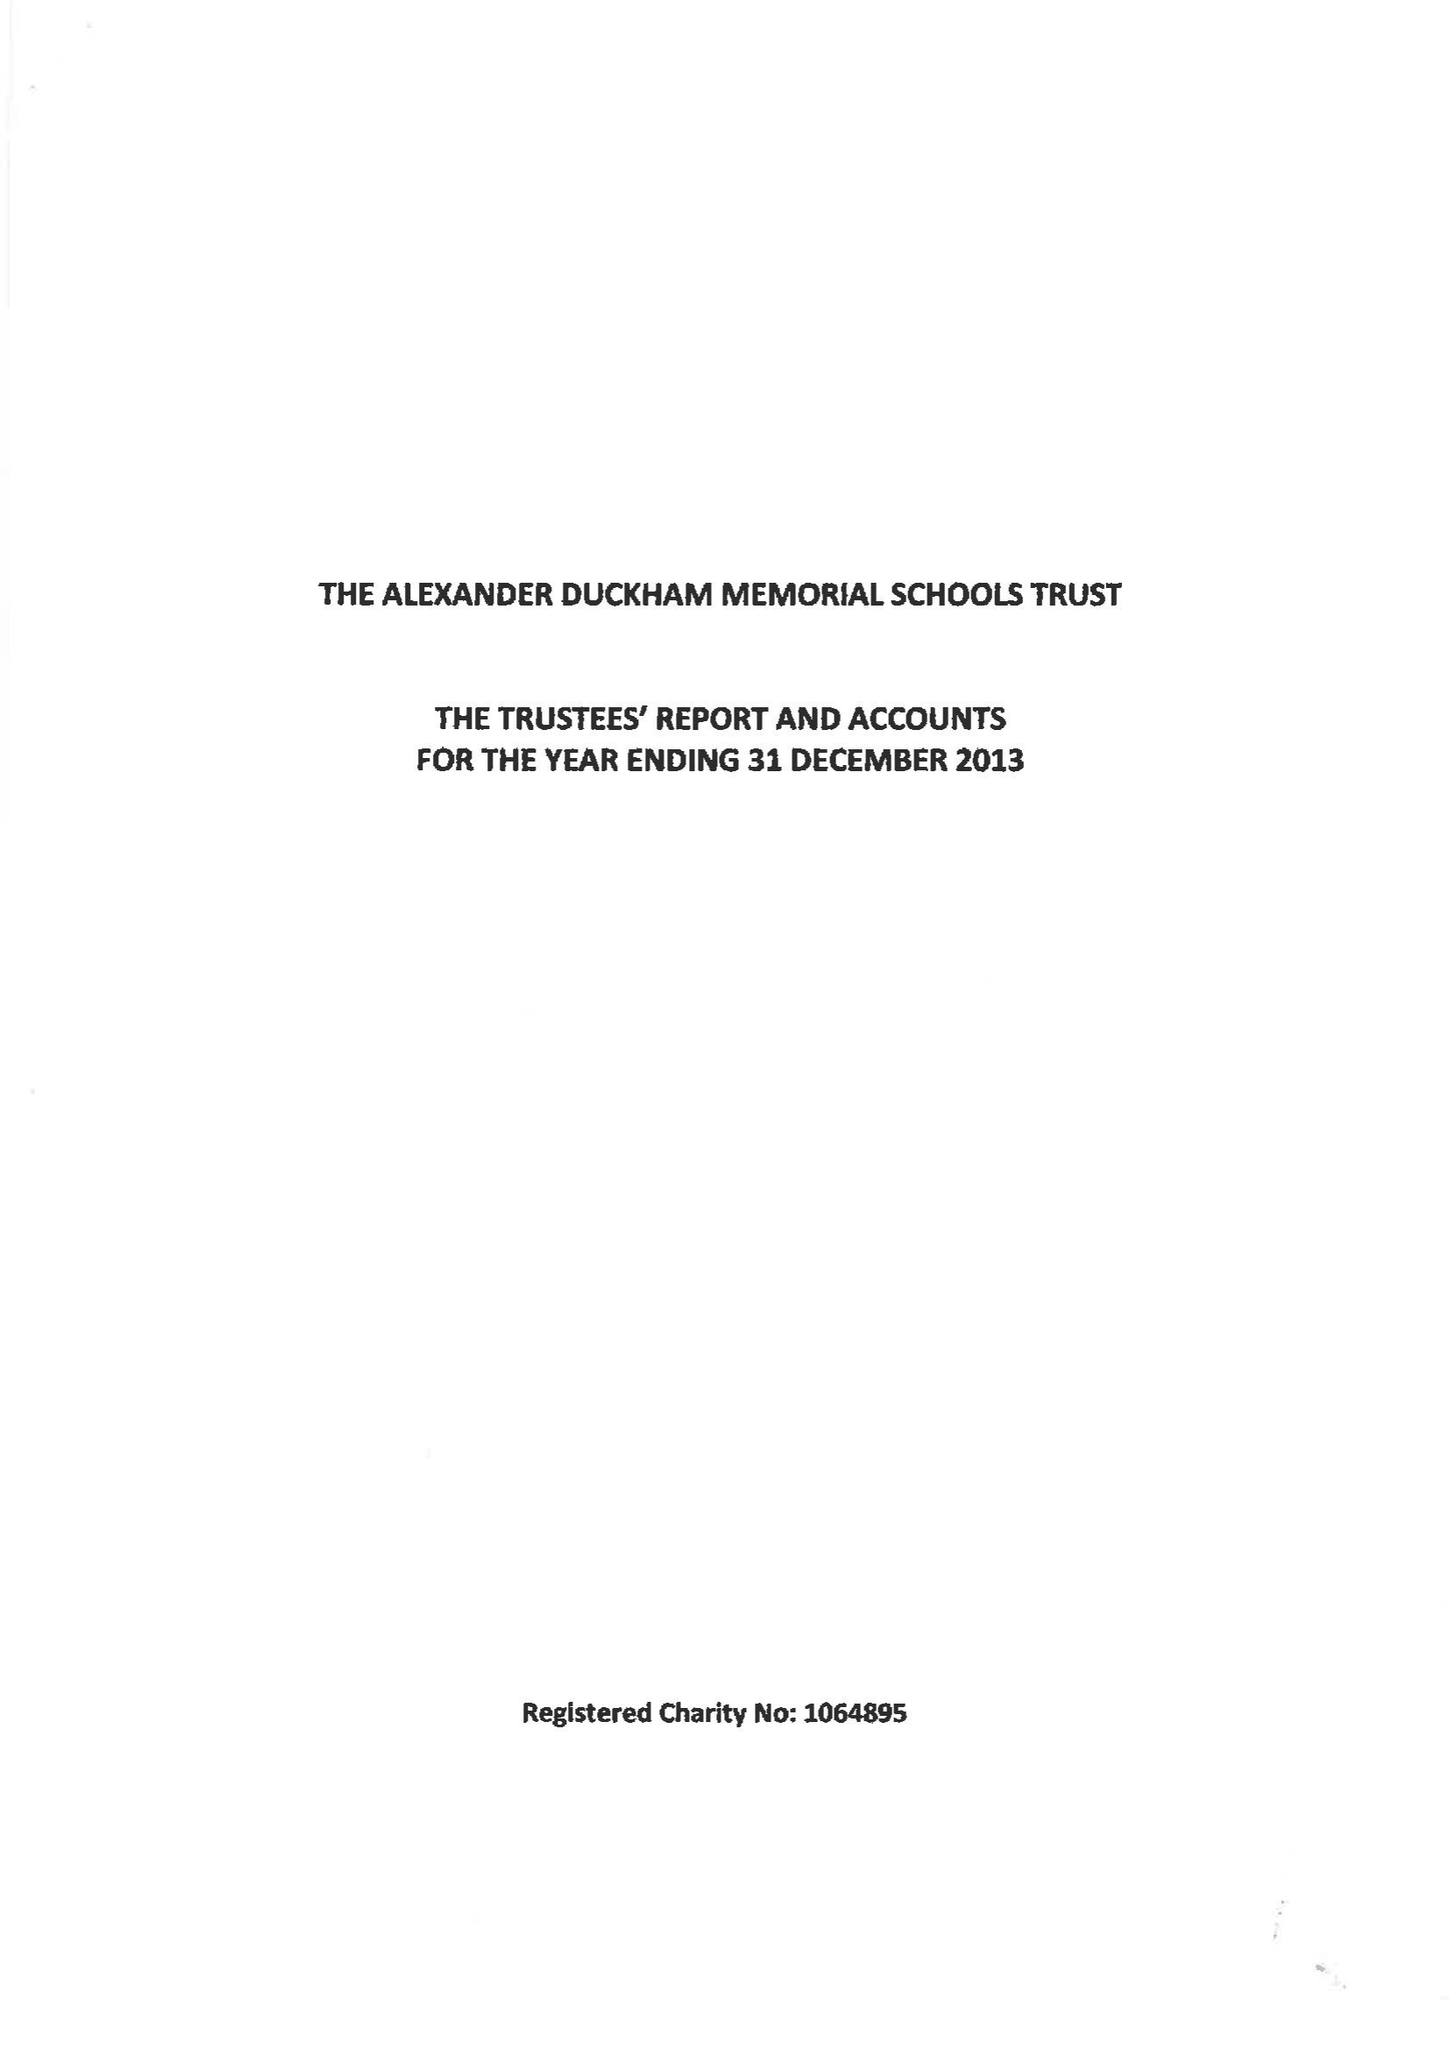What is the value for the report_date?
Answer the question using a single word or phrase. 2013-12-31 